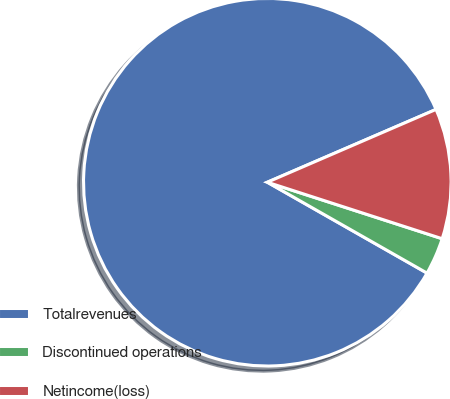<chart> <loc_0><loc_0><loc_500><loc_500><pie_chart><fcel>Totalrevenues<fcel>Discontinued operations<fcel>Netincome(loss)<nl><fcel>85.28%<fcel>3.26%<fcel>11.46%<nl></chart> 